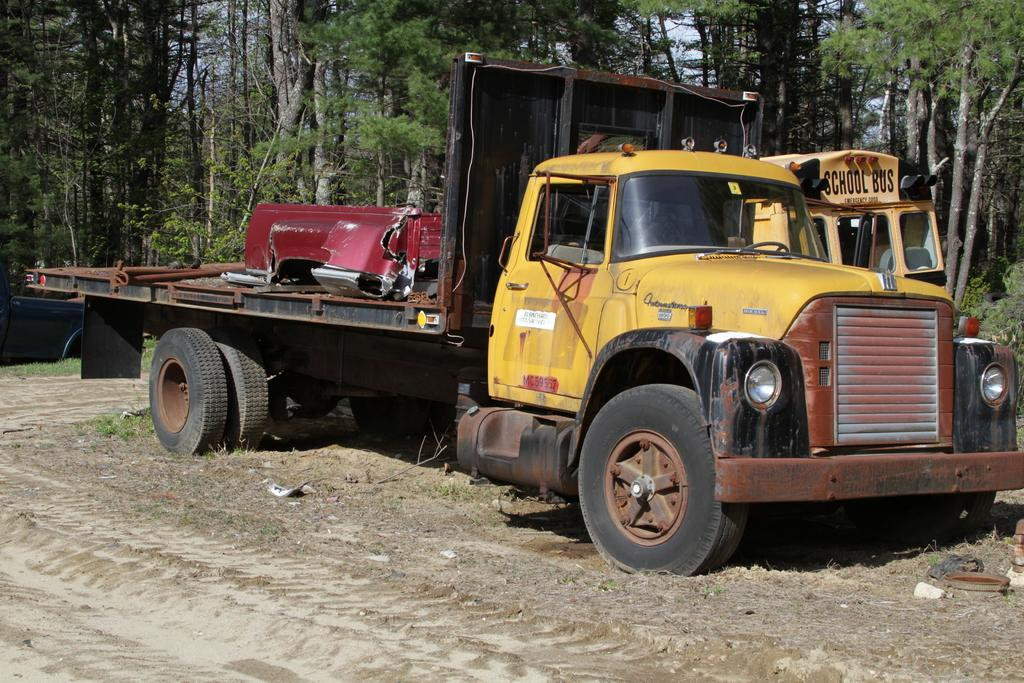What can be seen on the path in the image? There are vehicles parked on the path in the image. What type of natural elements are visible in the background of the image? There are trees visible in the background of the image. What is visible in the sky in the image? The sky is visible in the background of the image. What type of skate is being used by the tree in the image? There is no skate or tree using a skate in the image. 